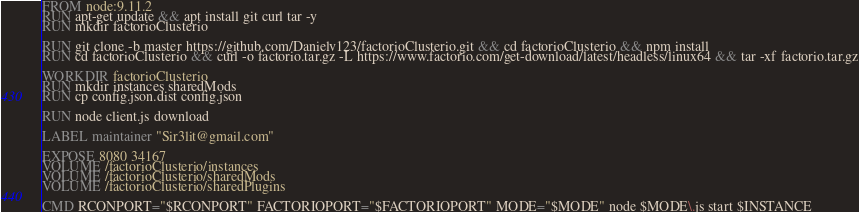Convert code to text. <code><loc_0><loc_0><loc_500><loc_500><_Dockerfile_>FROM node:9.11.2
RUN apt-get update && apt install git curl tar -y
RUN mkdir factorioClusterio

RUN git clone -b master https://github.com/Danielv123/factorioClusterio.git && cd factorioClusterio && npm install
RUN cd factorioClusterio && curl -o factorio.tar.gz -L https://www.factorio.com/get-download/latest/headless/linux64 && tar -xf factorio.tar.gz

WORKDIR factorioClusterio
RUN mkdir instances sharedMods
RUN cp config.json.dist config.json

RUN node client.js download

LABEL maintainer "Sir3lit@gmail.com"

EXPOSE 8080 34167
VOLUME /factorioClusterio/instances
VOLUME /factorioClusterio/sharedMods
VOLUME /factorioClusterio/sharedPlugins

CMD RCONPORT="$RCONPORT" FACTORIOPORT="$FACTORIOPORT" MODE="$MODE" node $MODE\.js start $INSTANCE
</code> 